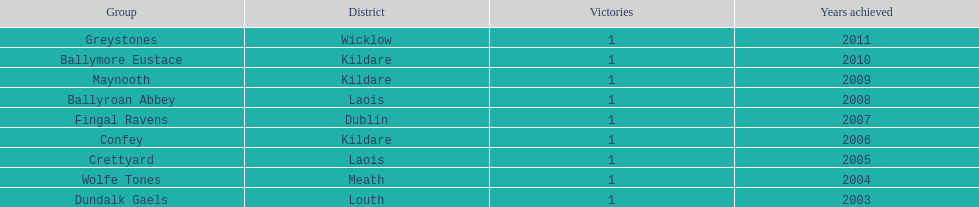How many wins does greystones have? 1. 